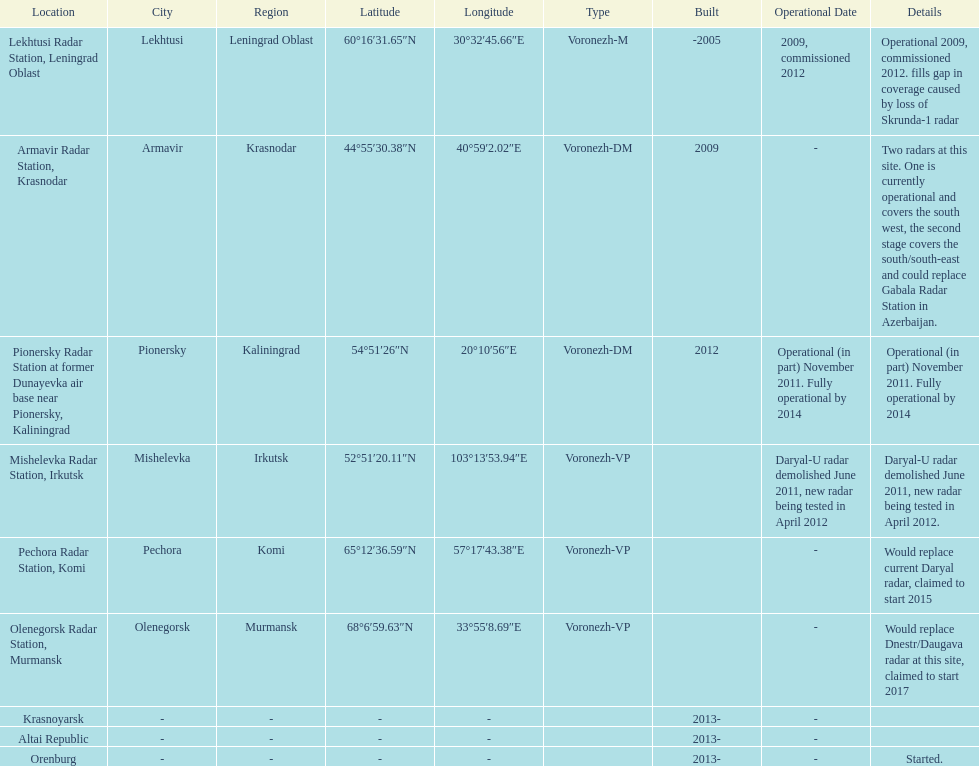How many voronezh radars were built before 2010? 2. 